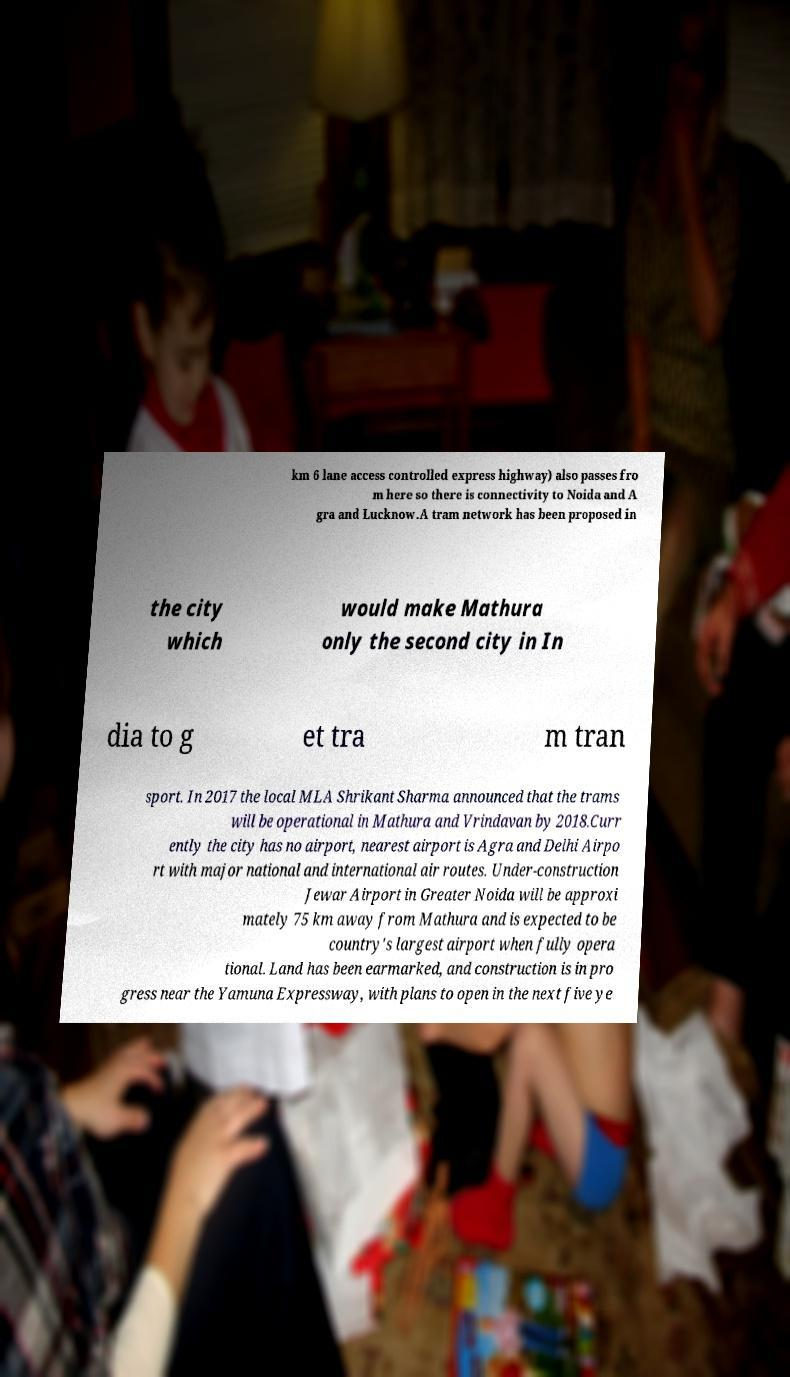Could you extract and type out the text from this image? km 6 lane access controlled express highway) also passes fro m here so there is connectivity to Noida and A gra and Lucknow.A tram network has been proposed in the city which would make Mathura only the second city in In dia to g et tra m tran sport. In 2017 the local MLA Shrikant Sharma announced that the trams will be operational in Mathura and Vrindavan by 2018.Curr ently the city has no airport, nearest airport is Agra and Delhi Airpo rt with major national and international air routes. Under-construction Jewar Airport in Greater Noida will be approxi mately 75 km away from Mathura and is expected to be country's largest airport when fully opera tional. Land has been earmarked, and construction is in pro gress near the Yamuna Expressway, with plans to open in the next five ye 